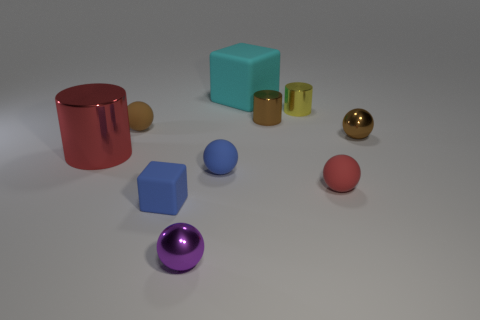There is a sphere that is both to the left of the cyan thing and behind the blue sphere; how big is it?
Your response must be concise. Small. How many blue matte balls have the same size as the blue cube?
Offer a terse response. 1. How many rubber objects are cyan objects or blue spheres?
Your answer should be compact. 2. What size is the ball that is the same color as the small rubber block?
Make the answer very short. Small. What material is the small brown thing that is in front of the small rubber sphere behind the large metallic object made of?
Make the answer very short. Metal. What number of objects are blue blocks or spheres that are behind the big metal cylinder?
Make the answer very short. 3. The brown ball that is made of the same material as the small red thing is what size?
Keep it short and to the point. Small. How many yellow things are big things or tiny metallic objects?
Your response must be concise. 1. The small rubber thing that is the same color as the small block is what shape?
Give a very brief answer. Sphere. Is there anything else that has the same material as the big cube?
Your response must be concise. Yes. 